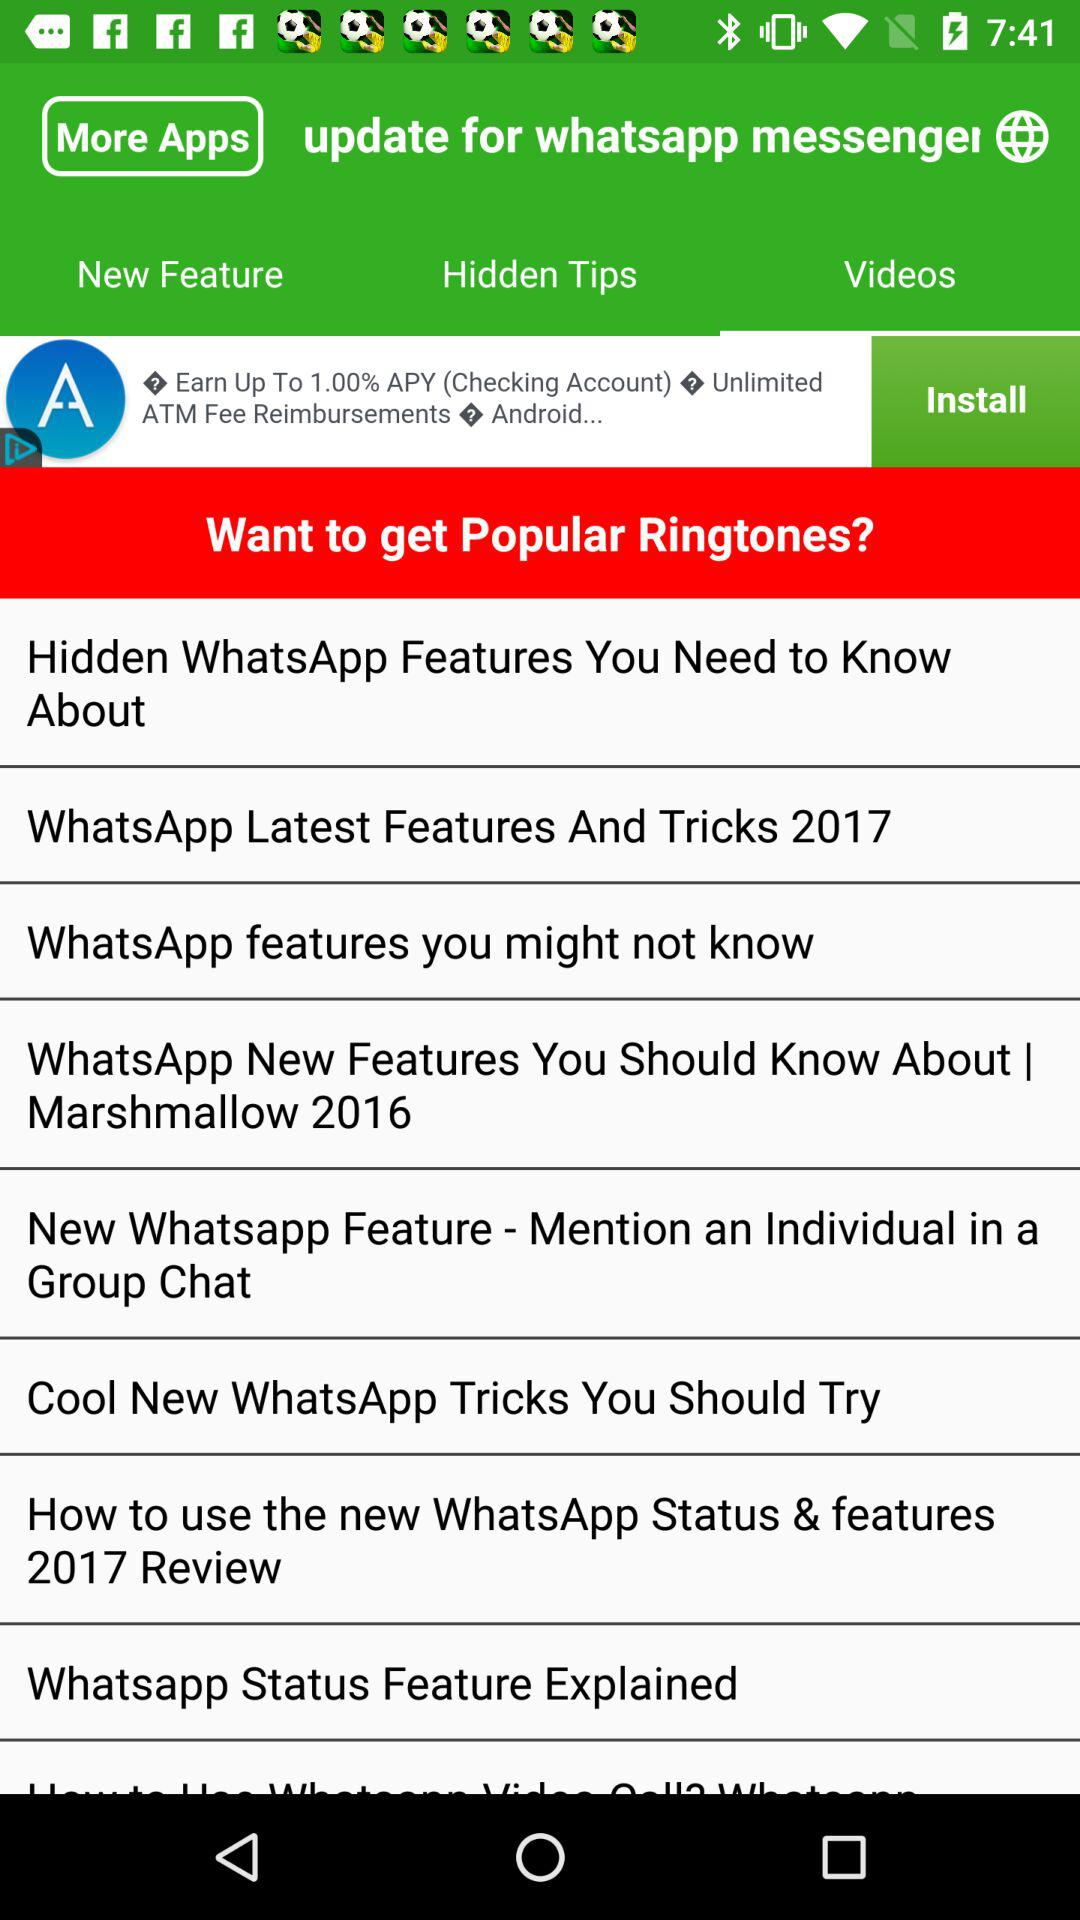What is the application name?
When the provided information is insufficient, respond with <no answer>. <no answer> 